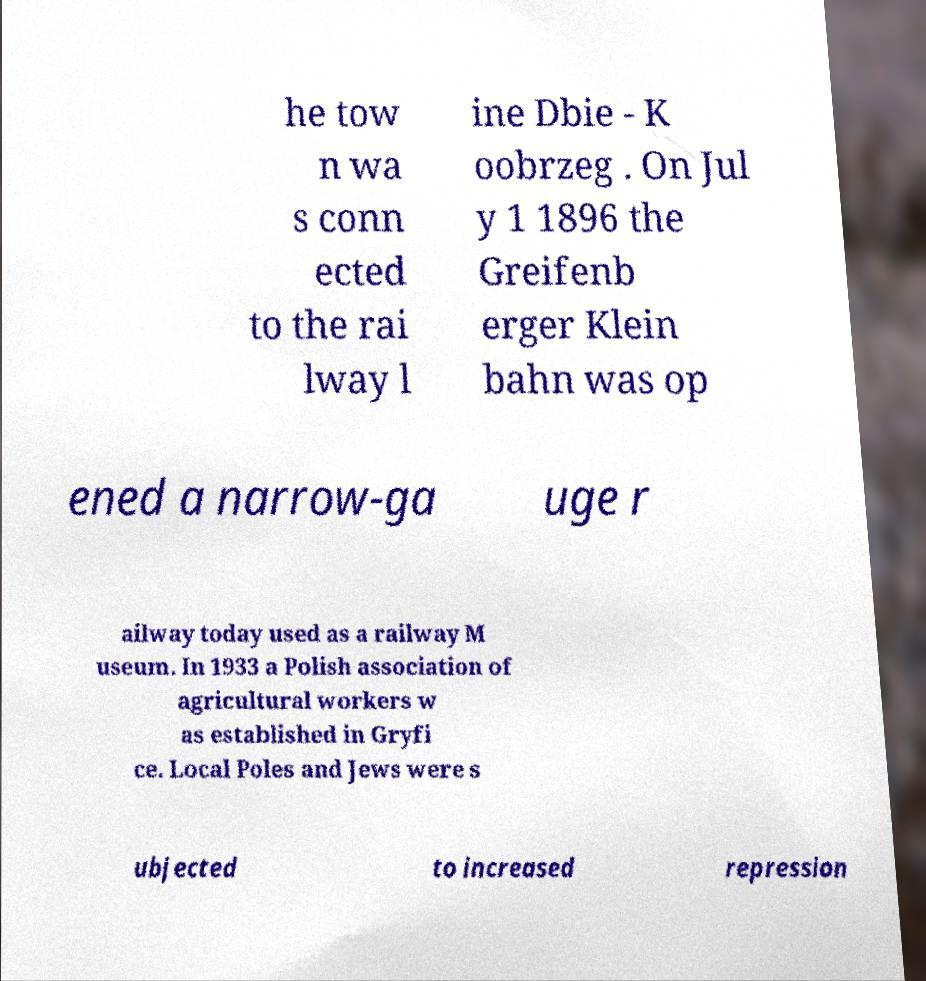Please identify and transcribe the text found in this image. he tow n wa s conn ected to the rai lway l ine Dbie - K oobrzeg . On Jul y 1 1896 the Greifenb erger Klein bahn was op ened a narrow-ga uge r ailway today used as a railway M useum. In 1933 a Polish association of agricultural workers w as established in Gryfi ce. Local Poles and Jews were s ubjected to increased repression 